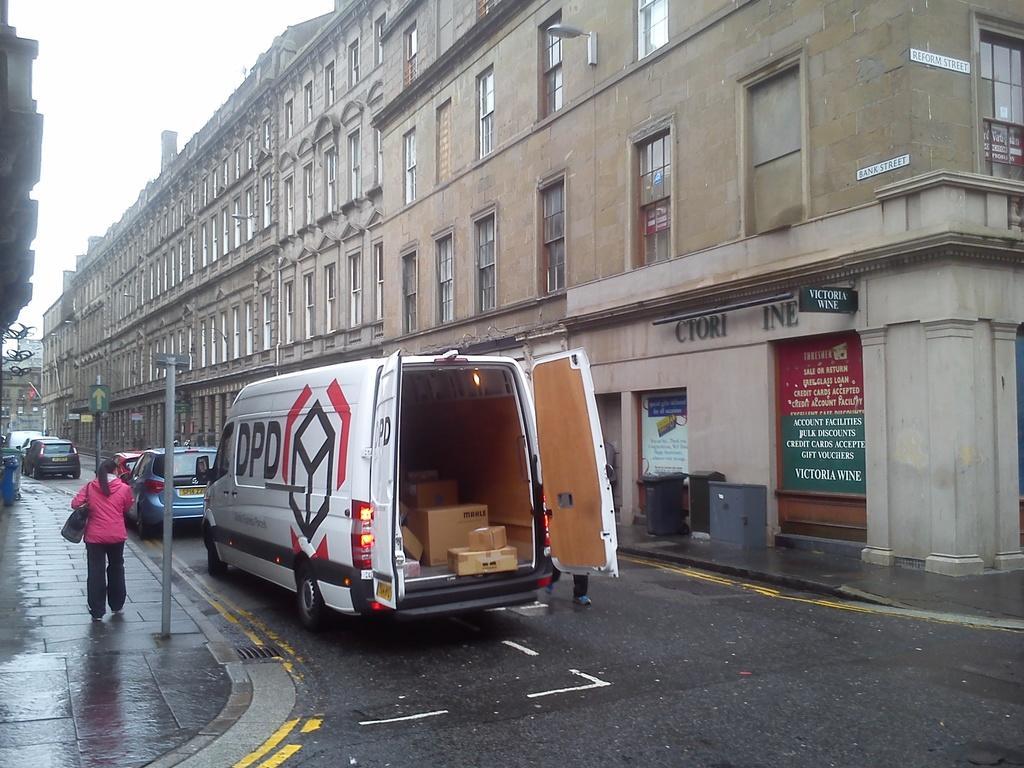Could you give a brief overview of what you see in this image? In the center of the image there is a road on which there are vehicles parked. There is a lady walking on the footpath. To the right side of the image there is a building. At the bottom of the image there is a road. 